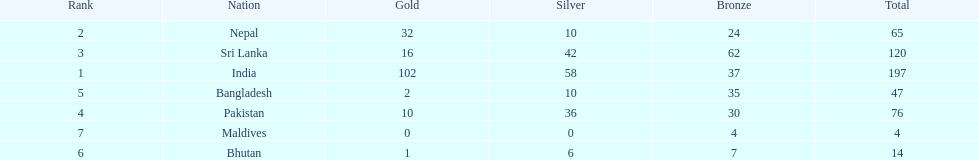What was the number of silver medals won by pakistan? 36. 